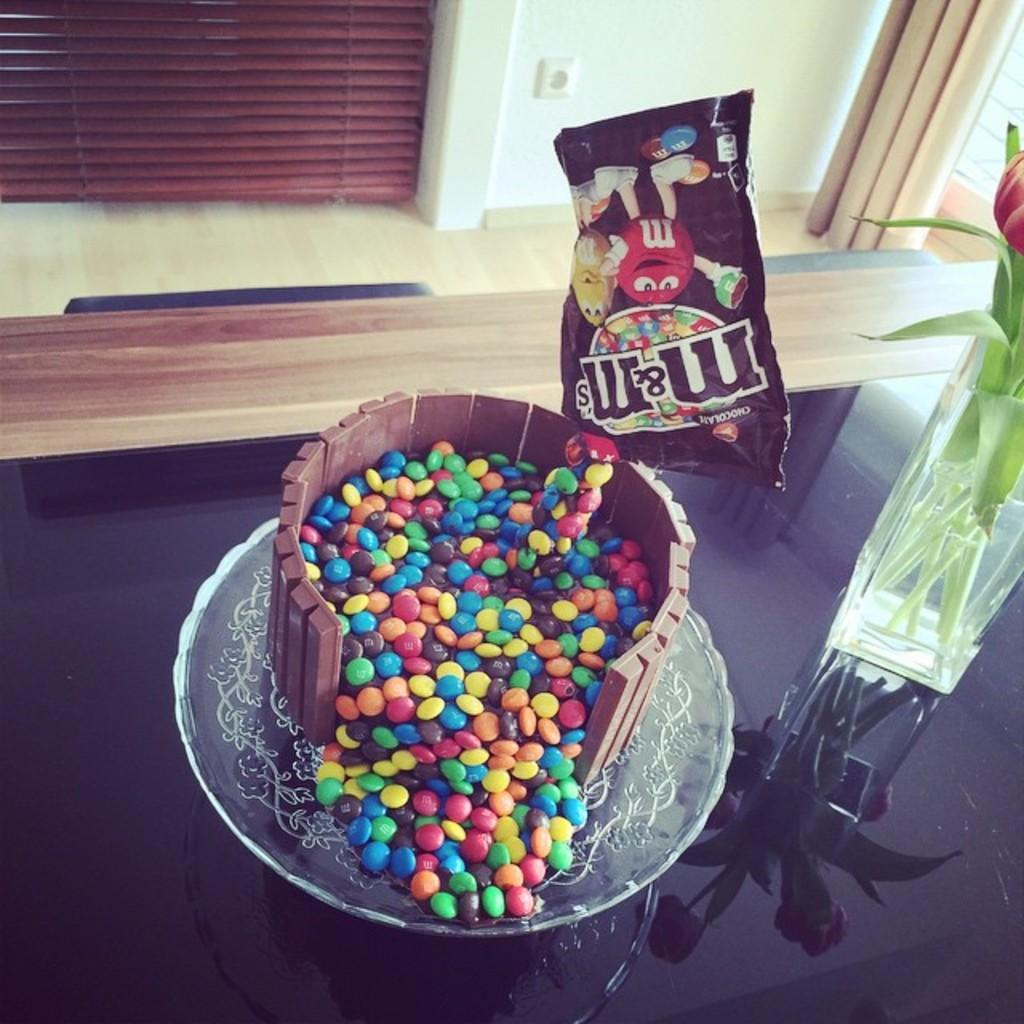In one or two sentences, can you explain what this image depicts? On a glass surface there is a vase with stems. Also there is a packet. And there is a plate. And there are sweets in different colors. In the back there is a curtain and a wall. 